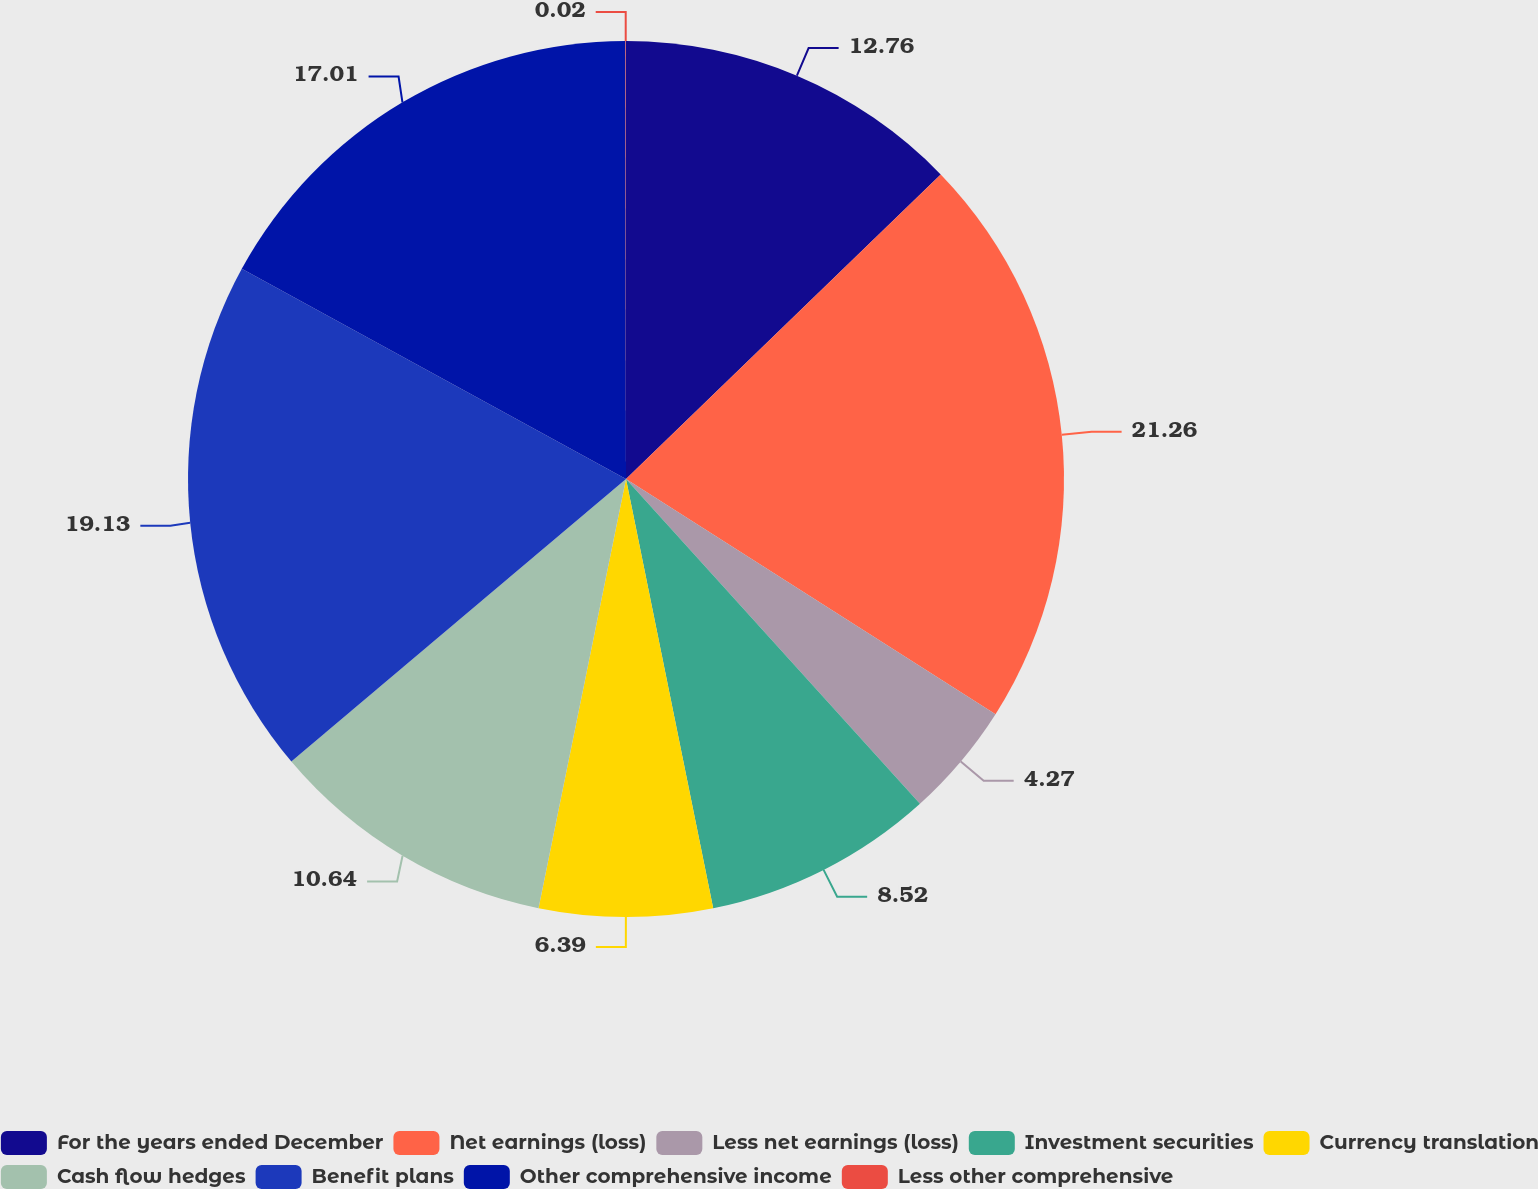Convert chart to OTSL. <chart><loc_0><loc_0><loc_500><loc_500><pie_chart><fcel>For the years ended December<fcel>Net earnings (loss)<fcel>Less net earnings (loss)<fcel>Investment securities<fcel>Currency translation<fcel>Cash flow hedges<fcel>Benefit plans<fcel>Other comprehensive income<fcel>Less other comprehensive<nl><fcel>12.76%<fcel>21.26%<fcel>4.27%<fcel>8.52%<fcel>6.39%<fcel>10.64%<fcel>19.13%<fcel>17.01%<fcel>0.02%<nl></chart> 